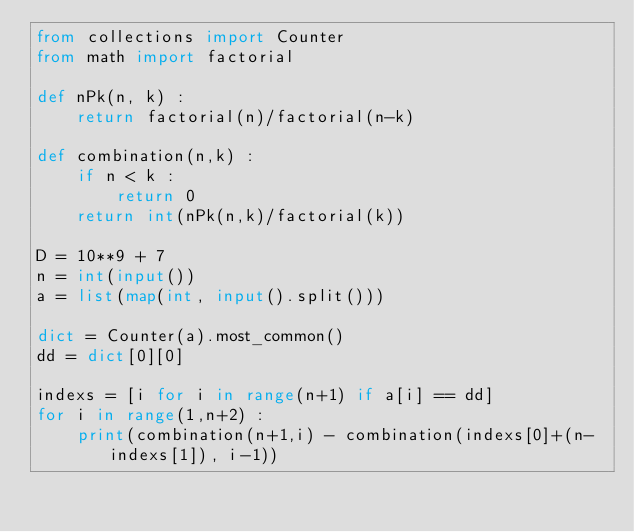<code> <loc_0><loc_0><loc_500><loc_500><_Python_>from collections import Counter
from math import factorial

def nPk(n, k) :
    return factorial(n)/factorial(n-k)

def combination(n,k) :
    if n < k :
        return 0
    return int(nPk(n,k)/factorial(k))

D = 10**9 + 7
n = int(input())
a = list(map(int, input().split()))

dict = Counter(a).most_common()
dd = dict[0][0]

indexs = [i for i in range(n+1) if a[i] == dd]
for i in range(1,n+2) :
    print(combination(n+1,i) - combination(indexs[0]+(n-indexs[1]), i-1))</code> 